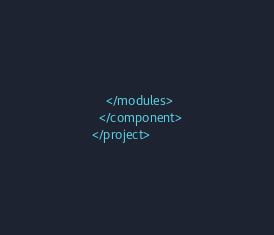Convert code to text. <code><loc_0><loc_0><loc_500><loc_500><_XML_>    </modules>
  </component>
</project></code> 